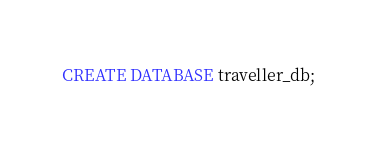Convert code to text. <code><loc_0><loc_0><loc_500><loc_500><_SQL_>CREATE DATABASE traveller_db;</code> 